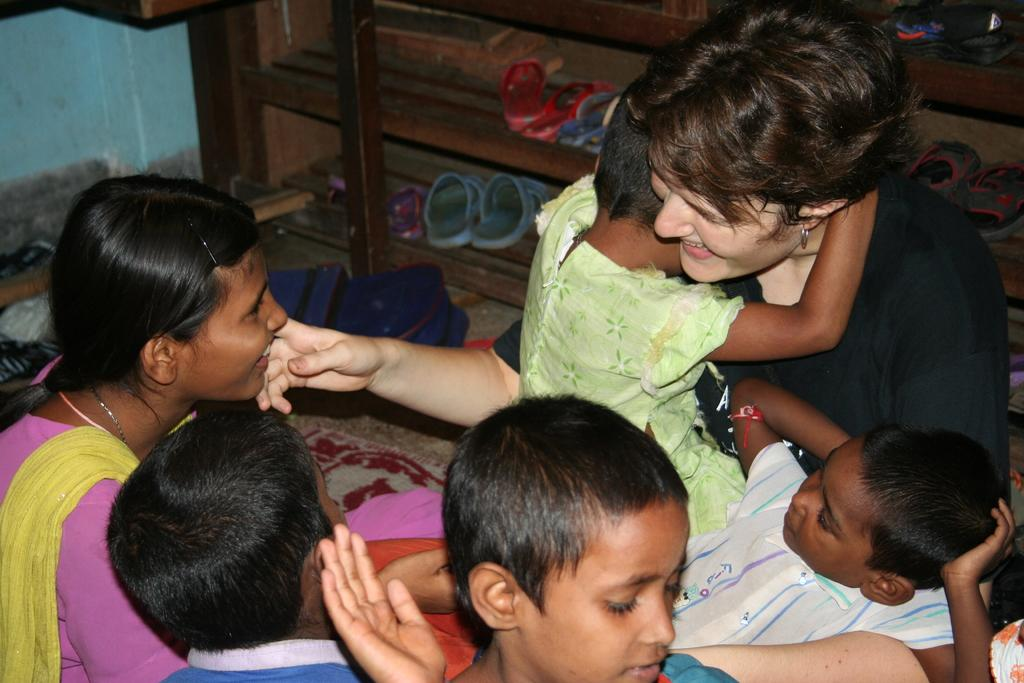What can be observed about the attire of the people in the image? There are people wearing different color dresses in the image. What can be seen in the background of the image? There is a wall visible in the background of the image. What type of object is present in the image that is made of wood? There are foot-wears on a wooden object in the image. What type of teeth can be seen on the scale in the image? There is no scale or teeth present in the image. 